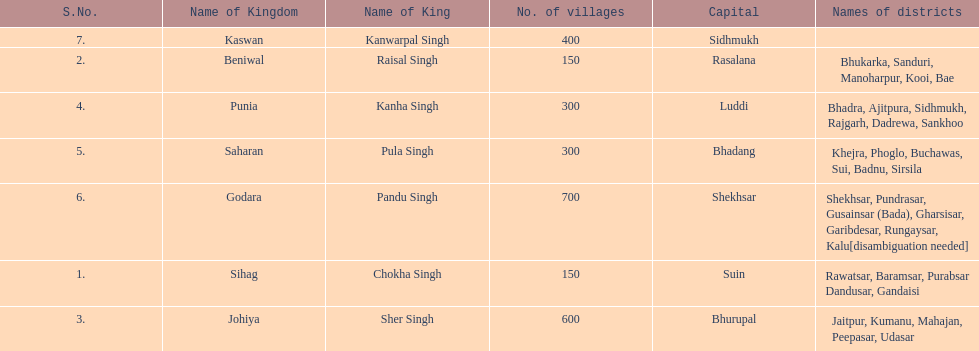Which kingdom contained the second most villages, next only to godara? Johiya. 